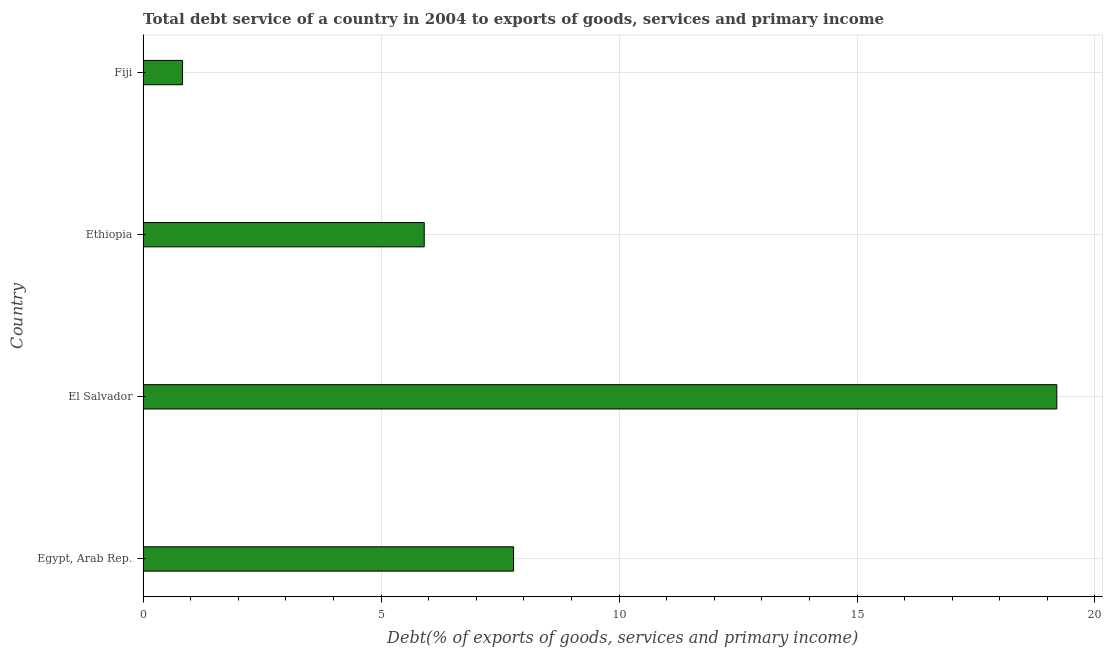Does the graph contain any zero values?
Make the answer very short. No. What is the title of the graph?
Give a very brief answer. Total debt service of a country in 2004 to exports of goods, services and primary income. What is the label or title of the X-axis?
Ensure brevity in your answer.  Debt(% of exports of goods, services and primary income). What is the total debt service in Ethiopia?
Your response must be concise. 5.91. Across all countries, what is the maximum total debt service?
Give a very brief answer. 19.2. Across all countries, what is the minimum total debt service?
Your response must be concise. 0.83. In which country was the total debt service maximum?
Keep it short and to the point. El Salvador. In which country was the total debt service minimum?
Keep it short and to the point. Fiji. What is the sum of the total debt service?
Keep it short and to the point. 33.72. What is the difference between the total debt service in Egypt, Arab Rep. and Ethiopia?
Make the answer very short. 1.88. What is the average total debt service per country?
Make the answer very short. 8.43. What is the median total debt service?
Offer a terse response. 6.85. What is the ratio of the total debt service in Egypt, Arab Rep. to that in Ethiopia?
Your answer should be very brief. 1.32. Is the difference between the total debt service in Ethiopia and Fiji greater than the difference between any two countries?
Your answer should be very brief. No. What is the difference between the highest and the second highest total debt service?
Your answer should be compact. 11.41. What is the difference between the highest and the lowest total debt service?
Your answer should be very brief. 18.37. How many countries are there in the graph?
Your answer should be compact. 4. What is the difference between two consecutive major ticks on the X-axis?
Provide a short and direct response. 5. Are the values on the major ticks of X-axis written in scientific E-notation?
Your answer should be compact. No. What is the Debt(% of exports of goods, services and primary income) in Egypt, Arab Rep.?
Your answer should be compact. 7.78. What is the Debt(% of exports of goods, services and primary income) in El Salvador?
Offer a very short reply. 19.2. What is the Debt(% of exports of goods, services and primary income) of Ethiopia?
Offer a very short reply. 5.91. What is the Debt(% of exports of goods, services and primary income) in Fiji?
Offer a terse response. 0.83. What is the difference between the Debt(% of exports of goods, services and primary income) in Egypt, Arab Rep. and El Salvador?
Offer a very short reply. -11.41. What is the difference between the Debt(% of exports of goods, services and primary income) in Egypt, Arab Rep. and Ethiopia?
Make the answer very short. 1.88. What is the difference between the Debt(% of exports of goods, services and primary income) in Egypt, Arab Rep. and Fiji?
Offer a terse response. 6.95. What is the difference between the Debt(% of exports of goods, services and primary income) in El Salvador and Ethiopia?
Give a very brief answer. 13.29. What is the difference between the Debt(% of exports of goods, services and primary income) in El Salvador and Fiji?
Provide a short and direct response. 18.37. What is the difference between the Debt(% of exports of goods, services and primary income) in Ethiopia and Fiji?
Provide a short and direct response. 5.08. What is the ratio of the Debt(% of exports of goods, services and primary income) in Egypt, Arab Rep. to that in El Salvador?
Give a very brief answer. 0.41. What is the ratio of the Debt(% of exports of goods, services and primary income) in Egypt, Arab Rep. to that in Ethiopia?
Ensure brevity in your answer.  1.32. What is the ratio of the Debt(% of exports of goods, services and primary income) in Egypt, Arab Rep. to that in Fiji?
Give a very brief answer. 9.38. What is the ratio of the Debt(% of exports of goods, services and primary income) in El Salvador to that in Fiji?
Offer a terse response. 23.14. What is the ratio of the Debt(% of exports of goods, services and primary income) in Ethiopia to that in Fiji?
Give a very brief answer. 7.12. 